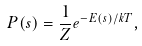Convert formula to latex. <formula><loc_0><loc_0><loc_500><loc_500>P ( s ) = { \frac { 1 } { Z } } e ^ { - E ( s ) / k T } ,</formula> 